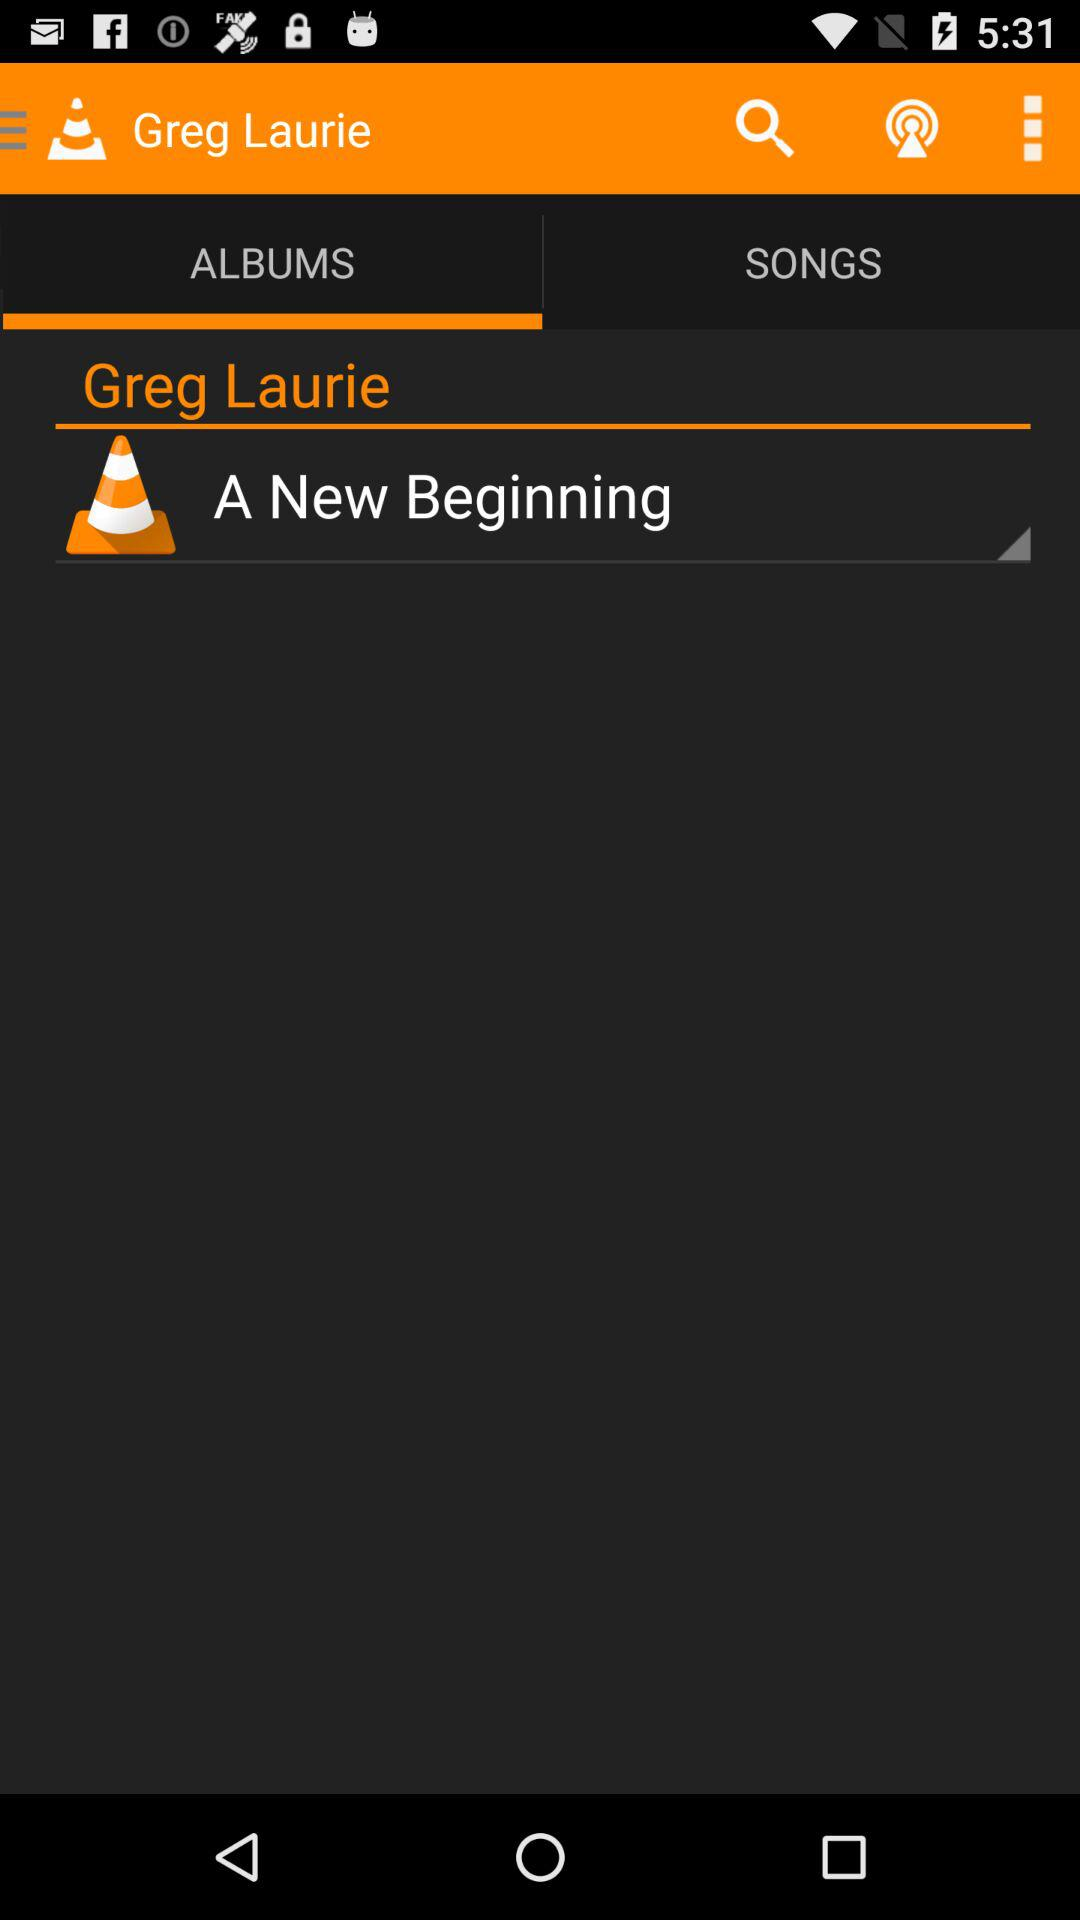What tab is selected right now? The selected tab is "ALBUMS". 